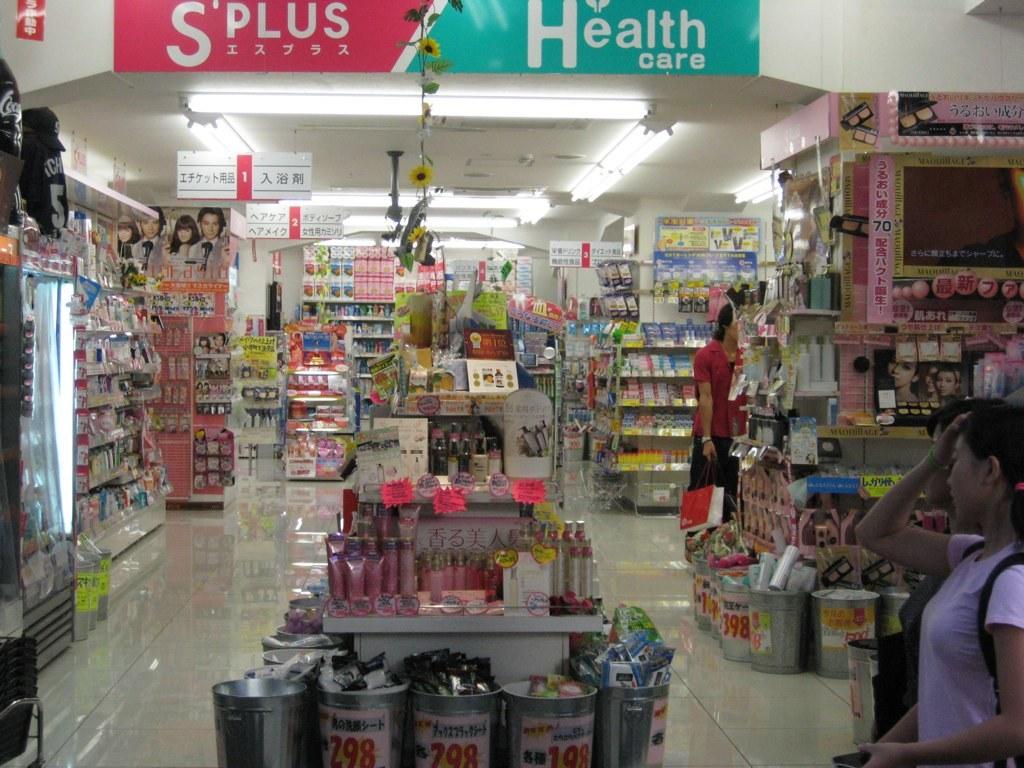What department is on the right side of store?
Provide a short and direct response. Health care. What is the first word on the sign at the top?
Your response must be concise. Plus. 